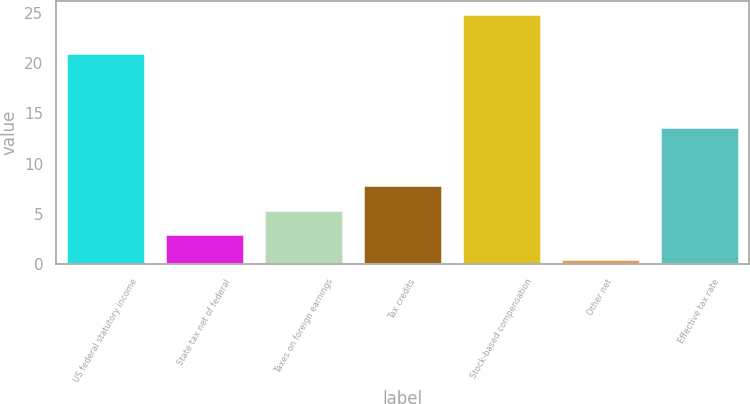Convert chart. <chart><loc_0><loc_0><loc_500><loc_500><bar_chart><fcel>US federal statutory income<fcel>State tax net of federal<fcel>Taxes on foreign earnings<fcel>Tax credits<fcel>Stock-based compensation<fcel>Other net<fcel>Effective tax rate<nl><fcel>21<fcel>2.97<fcel>5.41<fcel>7.85<fcel>24.9<fcel>0.53<fcel>13.61<nl></chart> 